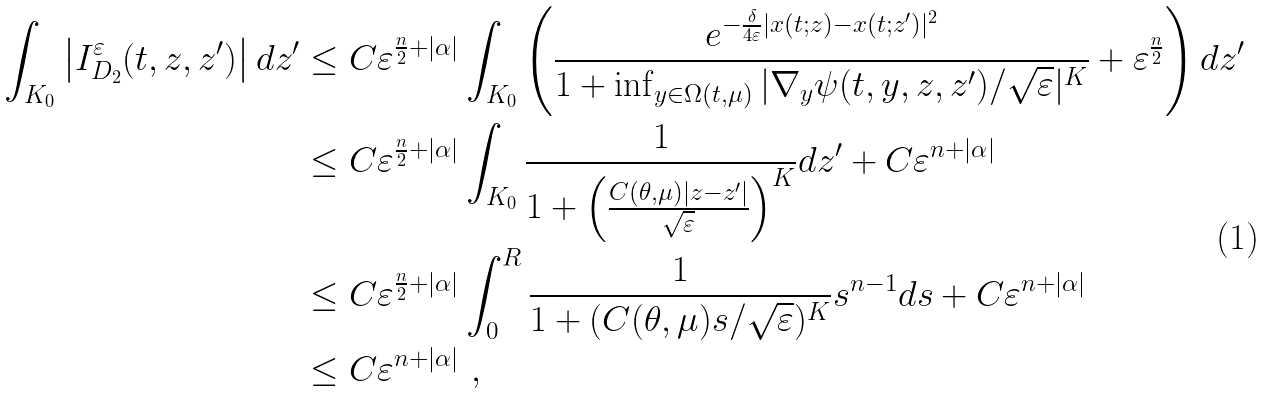Convert formula to latex. <formula><loc_0><loc_0><loc_500><loc_500>\int _ { K _ { 0 } } \left | I ^ { \varepsilon } _ { D _ { 2 } } ( t , z , z ^ { \prime } ) \right | d z ^ { \prime } & \leq C \varepsilon ^ { \frac { n } { 2 } + | \alpha | } \int _ { K _ { 0 } } \left ( \frac { e ^ { - \frac { \delta } { 4 \varepsilon } | x ( t ; z ) - x ( t ; z ^ { \prime } ) | ^ { 2 } } } { 1 + \inf _ { y \in \Omega ( t , \mu ) } | \nabla _ { y } \psi ( t , y , z , z ^ { \prime } ) / \sqrt { \varepsilon } | ^ { K } } + \varepsilon ^ { \frac { n } { 2 } } \right ) d z ^ { \prime } \\ & \leq C \varepsilon ^ { \frac { n } { 2 } + | \alpha | } \int _ { K _ { 0 } } \frac { 1 } { 1 + \left ( \frac { C ( \theta , \mu ) | z - z ^ { \prime } | } { \sqrt { \varepsilon } } \right ) ^ { K } } d z ^ { \prime } + C \varepsilon ^ { n + | \alpha | } \\ & \leq C \varepsilon ^ { \frac { n } { 2 } + | \alpha | } \int _ { 0 } ^ { R } \frac { 1 } { 1 + ( C ( \theta , \mu ) s / \sqrt { \varepsilon } ) ^ { K } } s ^ { n - 1 } d s + C \varepsilon ^ { n + | \alpha | } \\ & \leq C \varepsilon ^ { n + | \alpha | } \ ,</formula> 